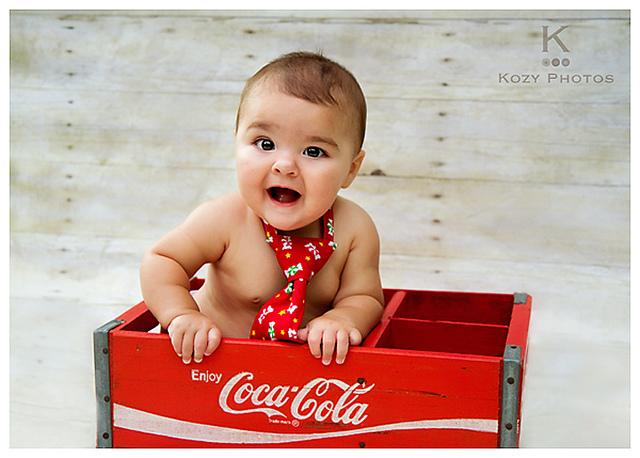Is this a recent photo?
Answer briefly. Yes. What brand/logo is written on the crate?
Answer briefly. Coca cola. Does the baby's tie match the color of the crate?
Be succinct. Yes. Is this picture staged?
Answer briefly. Yes. What is the child sitting on?
Give a very brief answer. Crate. 